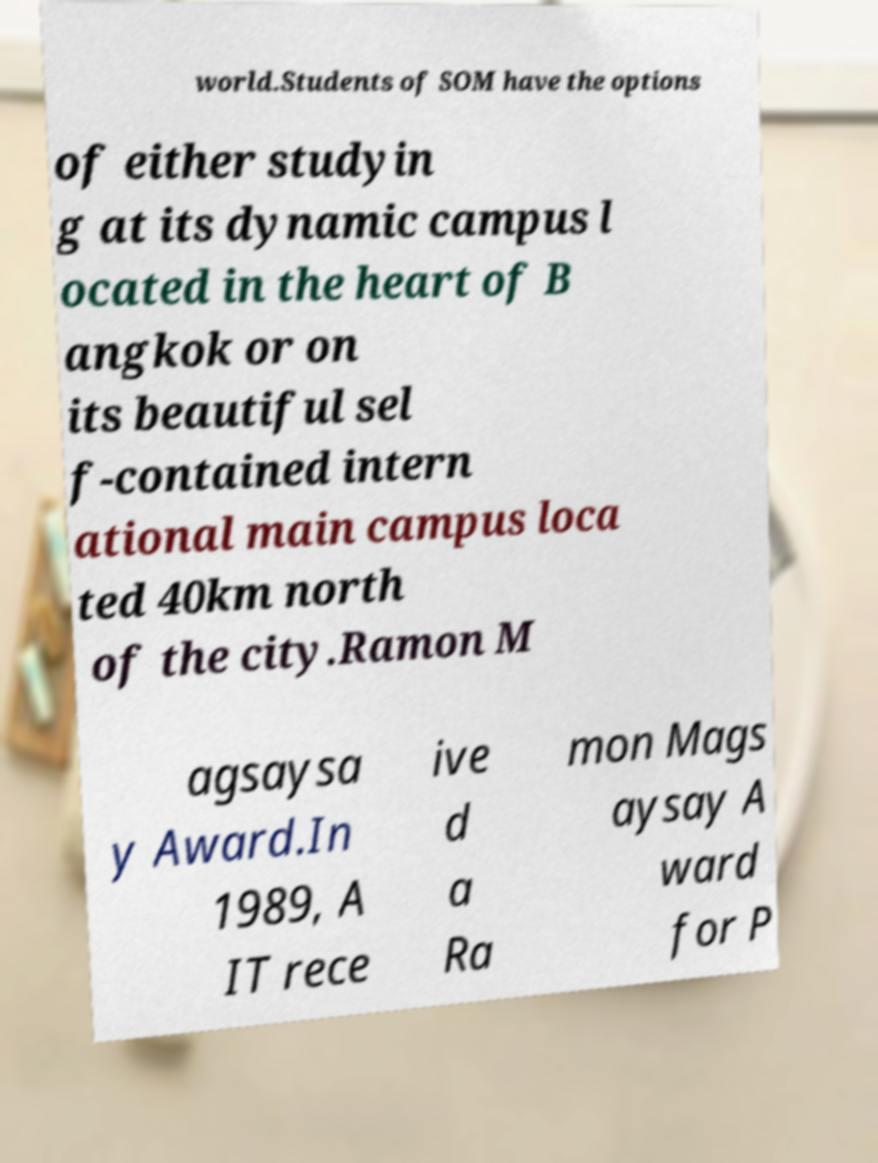Could you assist in decoding the text presented in this image and type it out clearly? world.Students of SOM have the options of either studyin g at its dynamic campus l ocated in the heart of B angkok or on its beautiful sel f-contained intern ational main campus loca ted 40km north of the city.Ramon M agsaysa y Award.In 1989, A IT rece ive d a Ra mon Mags aysay A ward for P 